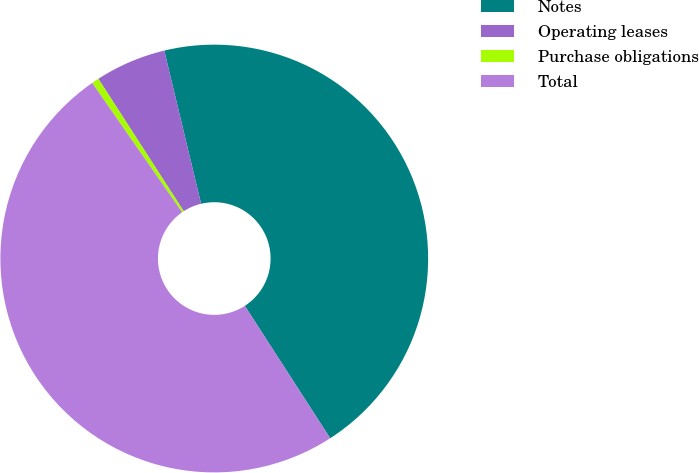<chart> <loc_0><loc_0><loc_500><loc_500><pie_chart><fcel>Notes<fcel>Operating leases<fcel>Purchase obligations<fcel>Total<nl><fcel>44.64%<fcel>5.36%<fcel>0.55%<fcel>49.45%<nl></chart> 